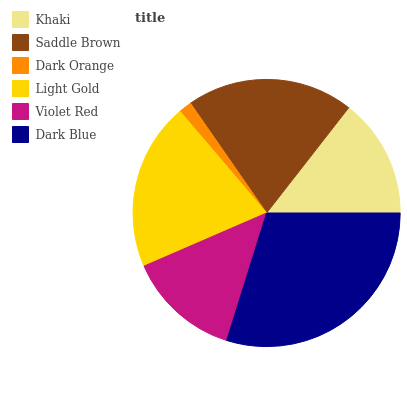Is Dark Orange the minimum?
Answer yes or no. Yes. Is Dark Blue the maximum?
Answer yes or no. Yes. Is Saddle Brown the minimum?
Answer yes or no. No. Is Saddle Brown the maximum?
Answer yes or no. No. Is Saddle Brown greater than Khaki?
Answer yes or no. Yes. Is Khaki less than Saddle Brown?
Answer yes or no. Yes. Is Khaki greater than Saddle Brown?
Answer yes or no. No. Is Saddle Brown less than Khaki?
Answer yes or no. No. Is Saddle Brown the high median?
Answer yes or no. Yes. Is Khaki the low median?
Answer yes or no. Yes. Is Violet Red the high median?
Answer yes or no. No. Is Saddle Brown the low median?
Answer yes or no. No. 